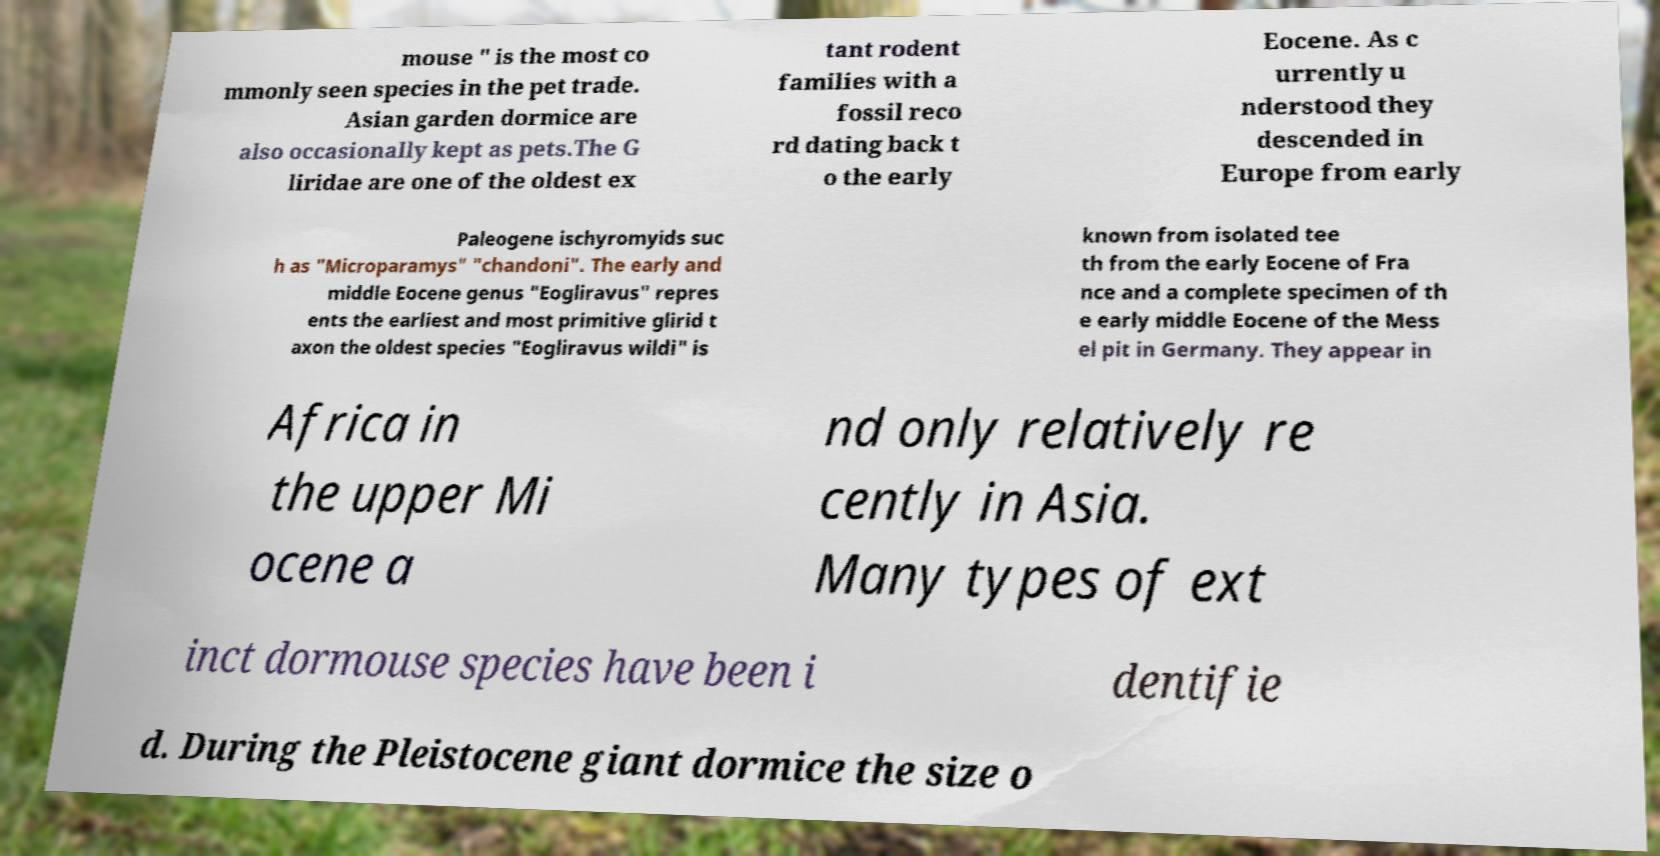Please identify and transcribe the text found in this image. mouse " is the most co mmonly seen species in the pet trade. Asian garden dormice are also occasionally kept as pets.The G liridae are one of the oldest ex tant rodent families with a fossil reco rd dating back t o the early Eocene. As c urrently u nderstood they descended in Europe from early Paleogene ischyromyids suc h as "Microparamys" "chandoni". The early and middle Eocene genus "Eogliravus" repres ents the earliest and most primitive glirid t axon the oldest species "Eogliravus wildi" is known from isolated tee th from the early Eocene of Fra nce and a complete specimen of th e early middle Eocene of the Mess el pit in Germany. They appear in Africa in the upper Mi ocene a nd only relatively re cently in Asia. Many types of ext inct dormouse species have been i dentifie d. During the Pleistocene giant dormice the size o 